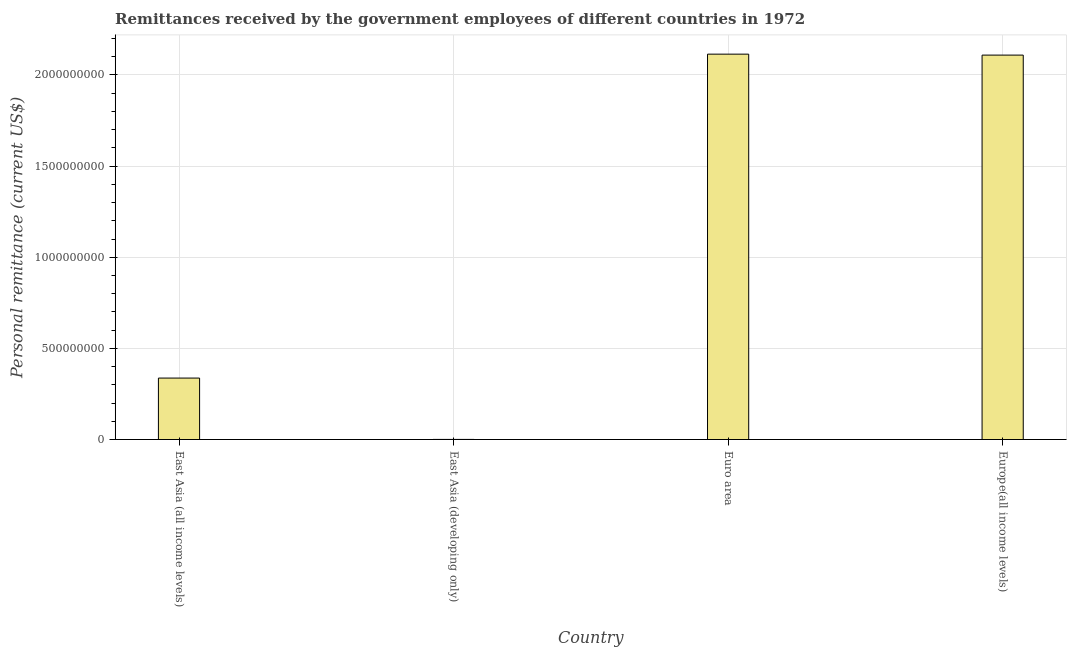Does the graph contain any zero values?
Offer a very short reply. No. What is the title of the graph?
Your answer should be very brief. Remittances received by the government employees of different countries in 1972. What is the label or title of the X-axis?
Your response must be concise. Country. What is the label or title of the Y-axis?
Ensure brevity in your answer.  Personal remittance (current US$). What is the personal remittances in Europe(all income levels)?
Offer a very short reply. 2.11e+09. Across all countries, what is the maximum personal remittances?
Your answer should be compact. 2.11e+09. Across all countries, what is the minimum personal remittances?
Give a very brief answer. 6.08e+05. In which country was the personal remittances maximum?
Provide a short and direct response. Euro area. In which country was the personal remittances minimum?
Ensure brevity in your answer.  East Asia (developing only). What is the sum of the personal remittances?
Offer a very short reply. 4.56e+09. What is the difference between the personal remittances in Euro area and Europe(all income levels)?
Offer a terse response. 5.22e+06. What is the average personal remittances per country?
Offer a very short reply. 1.14e+09. What is the median personal remittances?
Give a very brief answer. 1.22e+09. In how many countries, is the personal remittances greater than 2000000000 US$?
Provide a succinct answer. 2. What is the ratio of the personal remittances in East Asia (all income levels) to that in Euro area?
Make the answer very short. 0.16. Is the personal remittances in East Asia (developing only) less than that in Europe(all income levels)?
Your answer should be compact. Yes. Is the difference between the personal remittances in East Asia (all income levels) and Europe(all income levels) greater than the difference between any two countries?
Offer a terse response. No. What is the difference between the highest and the second highest personal remittances?
Keep it short and to the point. 5.22e+06. Is the sum of the personal remittances in Euro area and Europe(all income levels) greater than the maximum personal remittances across all countries?
Offer a very short reply. Yes. What is the difference between the highest and the lowest personal remittances?
Provide a short and direct response. 2.11e+09. How many bars are there?
Give a very brief answer. 4. What is the difference between two consecutive major ticks on the Y-axis?
Your answer should be compact. 5.00e+08. Are the values on the major ticks of Y-axis written in scientific E-notation?
Your response must be concise. No. What is the Personal remittance (current US$) of East Asia (all income levels)?
Keep it short and to the point. 3.37e+08. What is the Personal remittance (current US$) of East Asia (developing only)?
Ensure brevity in your answer.  6.08e+05. What is the Personal remittance (current US$) of Euro area?
Your answer should be very brief. 2.11e+09. What is the Personal remittance (current US$) of Europe(all income levels)?
Your answer should be compact. 2.11e+09. What is the difference between the Personal remittance (current US$) in East Asia (all income levels) and East Asia (developing only)?
Give a very brief answer. 3.37e+08. What is the difference between the Personal remittance (current US$) in East Asia (all income levels) and Euro area?
Offer a terse response. -1.78e+09. What is the difference between the Personal remittance (current US$) in East Asia (all income levels) and Europe(all income levels)?
Make the answer very short. -1.77e+09. What is the difference between the Personal remittance (current US$) in East Asia (developing only) and Euro area?
Your response must be concise. -2.11e+09. What is the difference between the Personal remittance (current US$) in East Asia (developing only) and Europe(all income levels)?
Offer a very short reply. -2.11e+09. What is the difference between the Personal remittance (current US$) in Euro area and Europe(all income levels)?
Your response must be concise. 5.22e+06. What is the ratio of the Personal remittance (current US$) in East Asia (all income levels) to that in East Asia (developing only)?
Offer a terse response. 554.58. What is the ratio of the Personal remittance (current US$) in East Asia (all income levels) to that in Euro area?
Your answer should be very brief. 0.16. What is the ratio of the Personal remittance (current US$) in East Asia (all income levels) to that in Europe(all income levels)?
Your response must be concise. 0.16. What is the ratio of the Personal remittance (current US$) in East Asia (developing only) to that in Europe(all income levels)?
Keep it short and to the point. 0. 